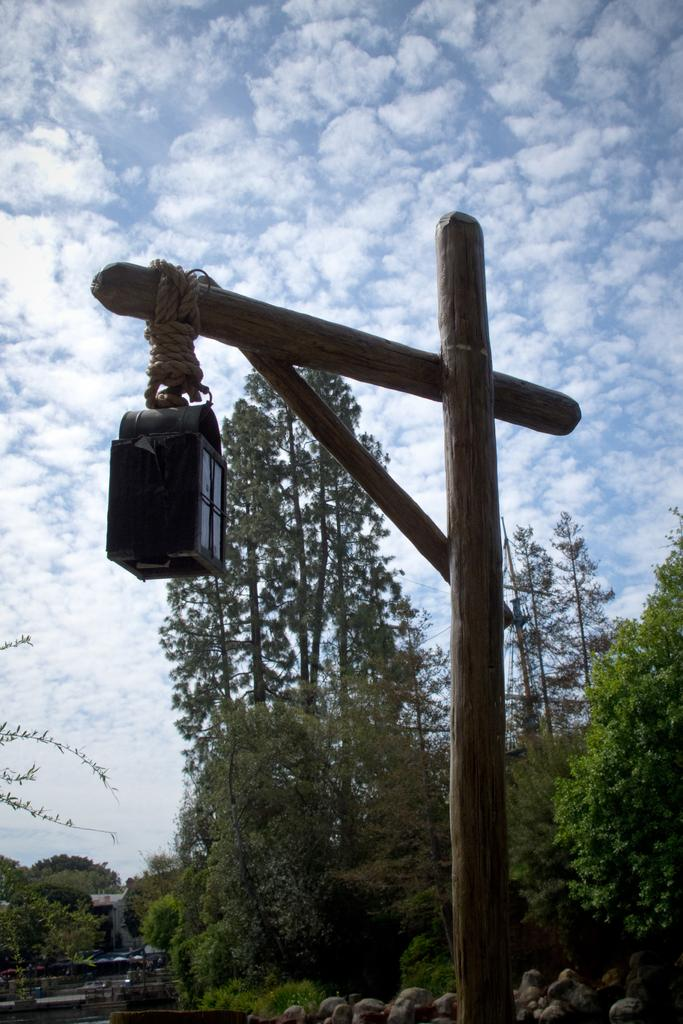What is the main structure in the picture? There is a wooden pillar in the picture. What is attached to the wooden pillar? The wooden pillar has a light attached to it. What type of natural elements can be seen in the picture? There are stones and trees in the picture. What is the condition of the sky in the picture? The sky is clear in the picture. Can you tell me how many people are in the group standing near the wooden pillar? There is no group of people present in the image; it only features a wooden pillar with a light attached to it, stones, trees, and a clear sky. What type of amusement can be seen in the picture? There is no amusement present in the image; it only features a wooden pillar with a light attached to it, stones, trees, and a clear sky. 